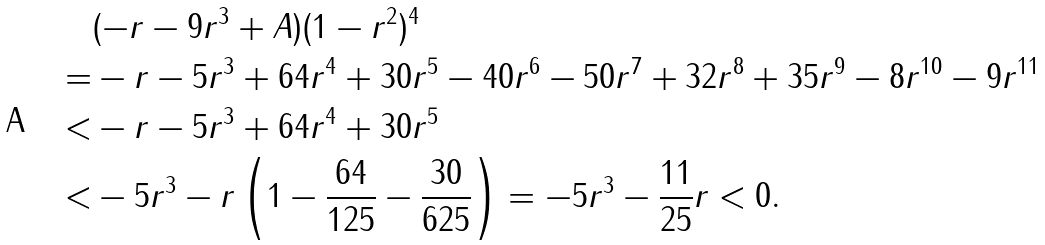<formula> <loc_0><loc_0><loc_500><loc_500>& ( - r - 9 r ^ { 3 } + A ) ( 1 - r ^ { 2 } ) ^ { 4 } \\ = & - r - 5 r ^ { 3 } + 6 4 r ^ { 4 } + 3 0 r ^ { 5 } - 4 0 r ^ { 6 } - 5 0 r ^ { 7 } + 3 2 r ^ { 8 } + 3 5 r ^ { 9 } - 8 r ^ { 1 0 } - 9 r ^ { 1 1 } \\ < & - r - 5 r ^ { 3 } + 6 4 r ^ { 4 } + 3 0 r ^ { 5 } \\ < & - 5 r ^ { 3 } - r \left ( 1 - \frac { 6 4 } { 1 2 5 } - \frac { 3 0 } { 6 2 5 } \right ) = - 5 r ^ { 3 } - \frac { 1 1 } { 2 5 } r < 0 .</formula> 